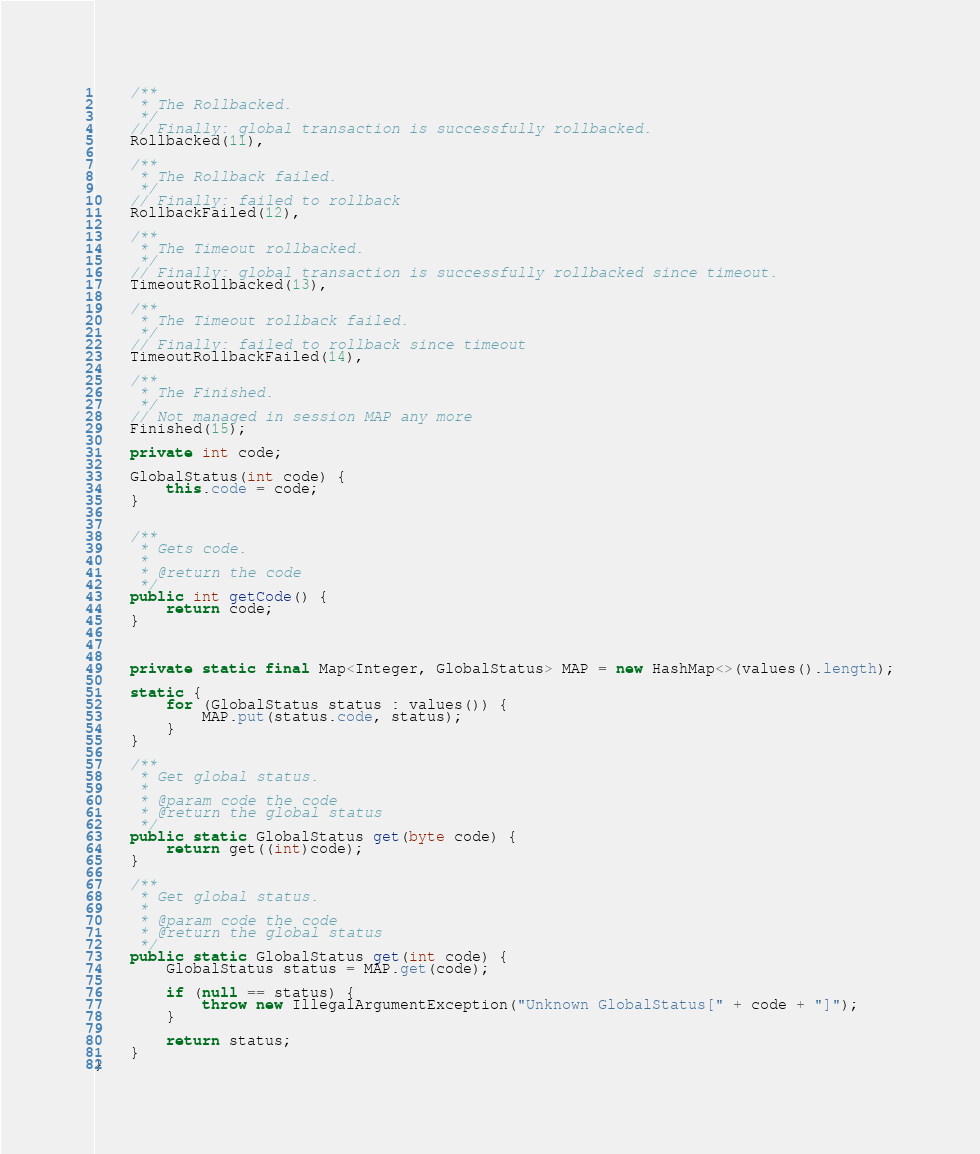<code> <loc_0><loc_0><loc_500><loc_500><_Java_>
    /**
     * The Rollbacked.
     */
    // Finally: global transaction is successfully rollbacked.
    Rollbacked(11),

    /**
     * The Rollback failed.
     */
    // Finally: failed to rollback
    RollbackFailed(12),

    /**
     * The Timeout rollbacked.
     */
    // Finally: global transaction is successfully rollbacked since timeout.
    TimeoutRollbacked(13),

    /**
     * The Timeout rollback failed.
     */
    // Finally: failed to rollback since timeout
    TimeoutRollbackFailed(14),

    /**
     * The Finished.
     */
    // Not managed in session MAP any more
    Finished(15);

    private int code;

    GlobalStatus(int code) {
        this.code = code;
    }


    /**
     * Gets code.
     *
     * @return the code
     */
    public int getCode() {
        return code;
    }



    private static final Map<Integer, GlobalStatus> MAP = new HashMap<>(values().length);

    static {
        for (GlobalStatus status : values()) {
            MAP.put(status.code, status);
        }
    }

    /**
     * Get global status.
     *
     * @param code the code
     * @return the global status
     */
    public static GlobalStatus get(byte code) {
        return get((int)code);
    }

    /**
     * Get global status.
     *
     * @param code the code
     * @return the global status
     */
    public static GlobalStatus get(int code) {
        GlobalStatus status = MAP.get(code);

        if (null == status) {
            throw new IllegalArgumentException("Unknown GlobalStatus[" + code + "]");
        }

        return status;
    }
}
</code> 